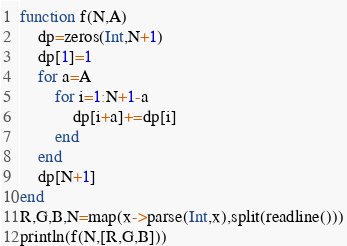<code> <loc_0><loc_0><loc_500><loc_500><_Julia_>function f(N,A)
	dp=zeros(Int,N+1)
	dp[1]=1
	for a=A
		for i=1:N+1-a
			dp[i+a]+=dp[i]
		end
	end
	dp[N+1]
end
R,G,B,N=map(x->parse(Int,x),split(readline()))
println(f(N,[R,G,B]))</code> 